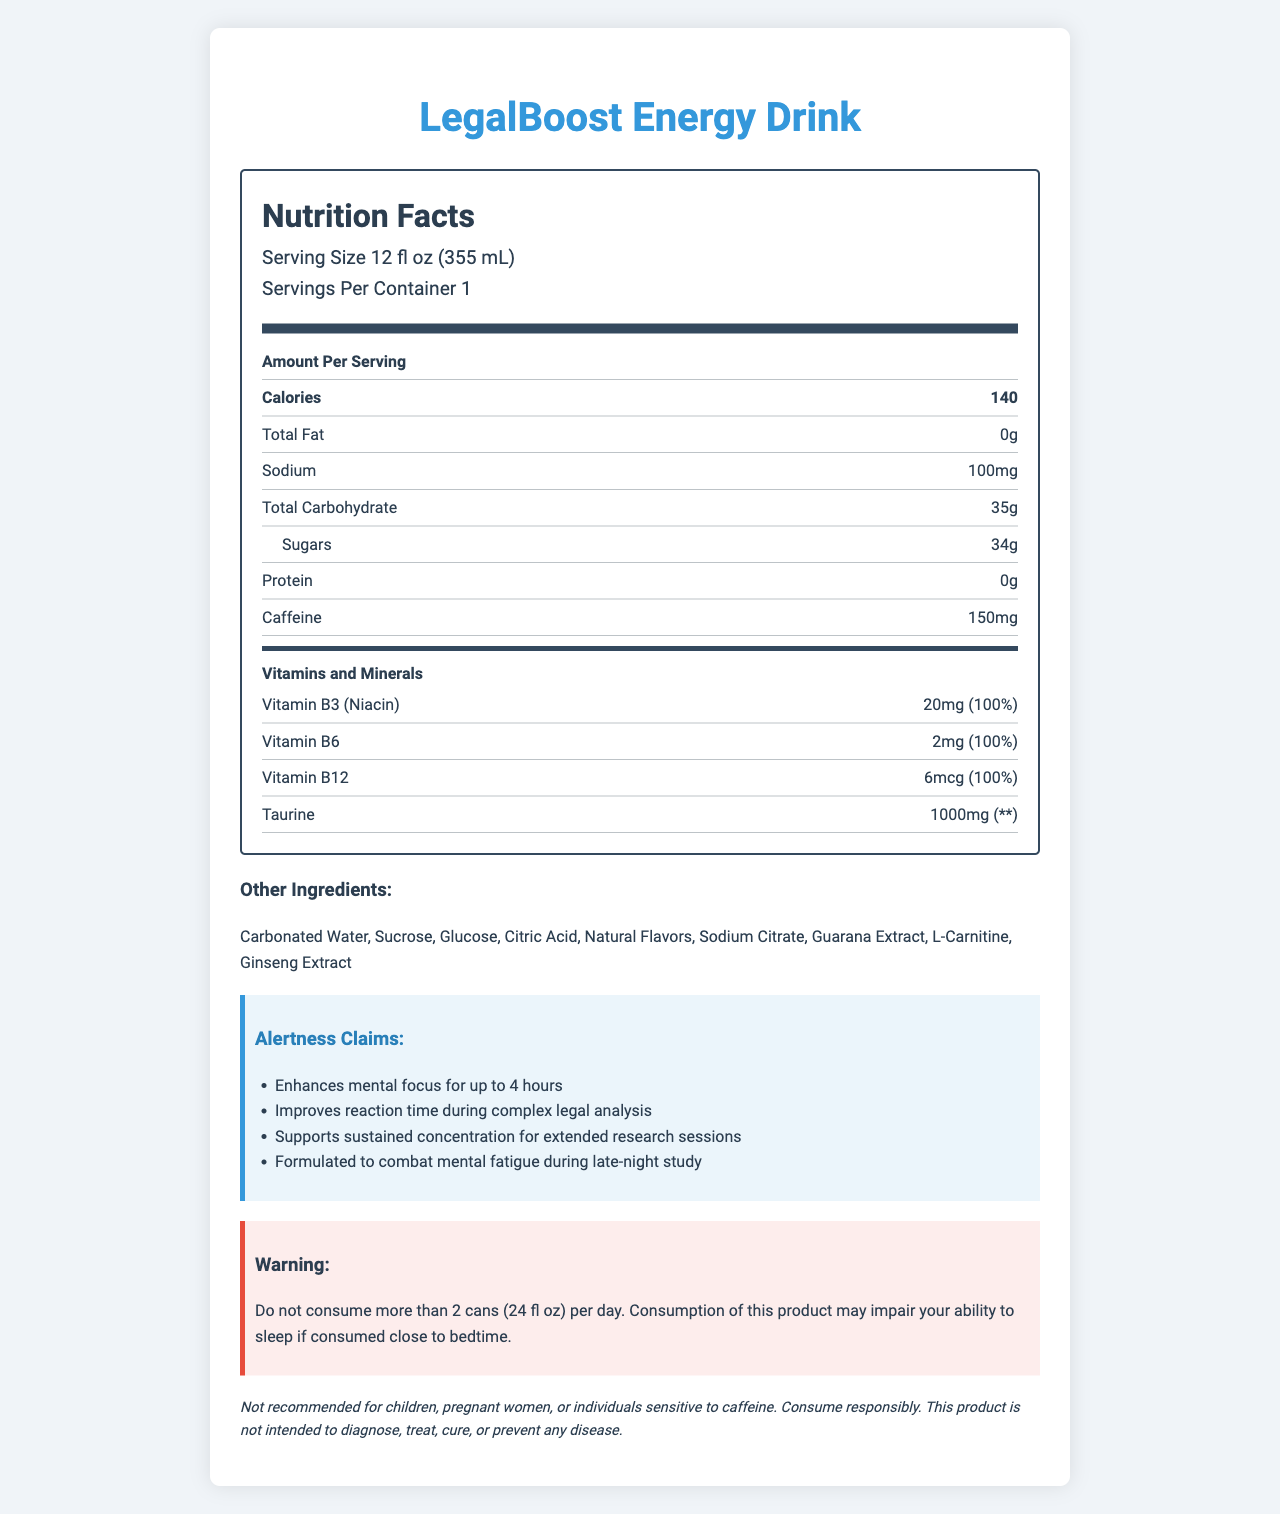what is the serving size of LegalBoost Energy Drink? The serving size is clearly stated below the title "Nutrition Facts".
Answer: 12 fl oz (355 mL) how much caffeine does one serving of LegalBoost Energy Drink contain? The caffeine content is listed among other nutrients in the "Nutrition Facts" section.
Answer: 150 mg list the vitamins and minerals included in LegalBoost Energy Drink. These vitamins and minerals are specified under the "Vitamins and Minerals" heading with specific amounts and daily values.
Answer: Vitamin B3 (Niacin), Vitamin B6, Vitamin B12, Taurine what is the sodium content per serving? The sodium content can be found in the breakdown of the nutrient facts.
Answer: 100 mg what is the main source of calories in this drink? The drink contains 34g of sugars, which is the most significant source of calories listed in the nutrition information.
Answer: Sugars which of the following is an ingredient in this drink? 
A. Aspartame 
B. High Fructose Corn Syrup 
C. Guarana Extract 
D. Artificial Flavors Guarana Extract is listed under "Other Ingredients"; the other options are not listed.
Answer: C. Guarana Extract how many servings are there per container? 
A. 1 
B. 2 
C. 3 
D. 4 The document indicates that there is 1 serving per container.
Answer: A. 1 what is the recommended daily limit of this drink? 
A. 2 cans 
B. 3 cans 
C. 4 cans 
D. None The warning section states not to consume more than 2 cans (24 fl oz) per day.
Answer: A. 2 cans can children consume this drink? The legal disclaimer explicitly advises that it is not recommended for children.
Answer: No describe the intended use of the LegalBoost Energy Drink. The document highlights these points in the "Alertness Claims" and "Product Benefits" sections.
Answer: The LegalBoost Energy Drink is designed to enhance mental focus, improve reaction time, support sustained concentration, and combat mental fatigue during intensive study sessions, especially for legal professionals and researchers. what is the environmental impact of the drink's packaging? The environmental impact section mentions that the can is made from recyclable aluminum and encourages responsible recycling.
Answer: The can is made from 100% recyclable aluminum. is Taurine listed with a daily value percentage? Taurine is listed under "Vitamins and Minerals" section with '**' indicating it does not have a daily value percentage.
Answer: No can the amount of Vitamin B6 in the drink meet 100% of the daily value requirements? Vitamin B6 is listed with an amount of 2 mg and a daily value percentage of 100%.
Answer: Yes how many calories are in a serving of LegalBoost Energy Drink? The calorie content per serving is listed under the "Nutrition Facts".
Answer: 140 is the LegalBoost Energy Drink compliant with FDA regulations for dietary supplements and energy drinks? The regulatory information section confirms that the drink complies with FDA regulations.
Answer: Yes what is the protein content per serving? The protein content is shown in the nutrient facts section and is listed as 0 grams.
Answer: 0 g how much Vitamin B3 (Niacin) is in the drink? The drink contains 20 mg of Vitamin B3, as listed in the "Vitamins and Minerals" section.
Answer: 20 mg is it possible to determine the exact effect of this drink on a person's ability to sleep? While the consumption warning suggests that consumption close to bedtime may impair sleep, it does not provide precise details about the effect on sleep for every individual.
Answer: Cannot be determined 